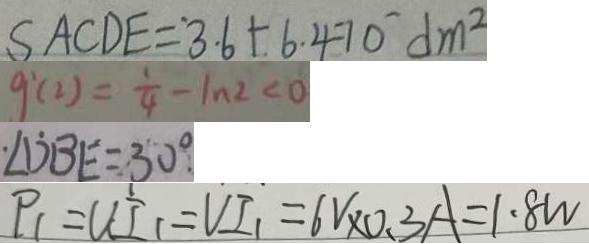Convert formula to latex. <formula><loc_0><loc_0><loc_500><loc_500>S A C D E = 3 . 6 + 6 . 4 7 0 d m ^ { 2 } 
 g ^ { \prime } ( 2 ) = \frac { 1 } { 4 } - \ln 2 < 0 
 \cdot \angle D B E = 3 0 ^ { \circ } . 
 P _ { 1 } = U I _ { 1 } = V I _ { 1 } = 6 V \times 0 . 3 A = 1 . 8 W</formula> 